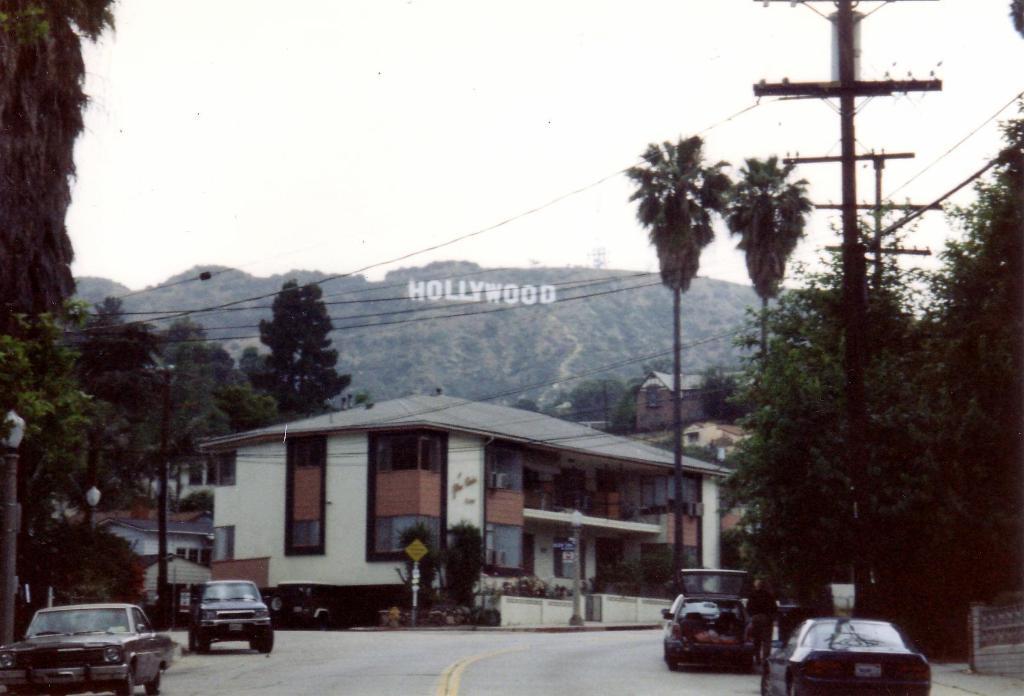Please provide a concise description of this image. In this there are buildings and trees. We can see poles and there are wires. At the bottom there is a road and we can see cars on the road. In the background there are hills and sky. 